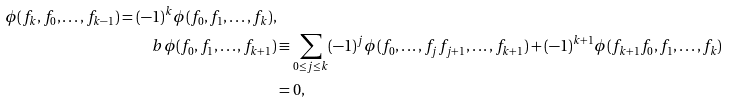<formula> <loc_0><loc_0><loc_500><loc_500>\phi ( f _ { k } , f _ { 0 } , \dots , f _ { k - 1 } ) = ( - 1 ) ^ { k } \phi ( f _ { 0 } , f _ { 1 } , \dots , f _ { k } ) , \\ b \phi ( f _ { 0 } , f _ { 1 } , \dots , f _ { k + 1 } ) & \equiv \sum _ { 0 \leq j \leq k } ( - 1 ) ^ { j } \phi ( f _ { 0 } , \dots , f _ { j } f _ { j + 1 } , \dots , f _ { k + 1 } ) + ( - 1 ) ^ { k + 1 } \phi ( f _ { k + 1 } f _ { 0 } , f _ { 1 } , \dots , f _ { k } ) \\ & = 0 ,</formula> 